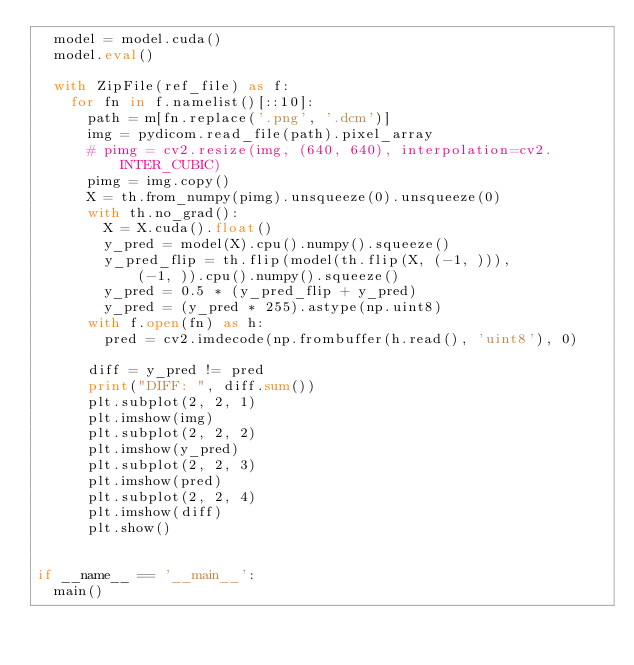<code> <loc_0><loc_0><loc_500><loc_500><_Python_>  model = model.cuda()
  model.eval()

  with ZipFile(ref_file) as f:
    for fn in f.namelist()[::10]:
      path = m[fn.replace('.png', '.dcm')]
      img = pydicom.read_file(path).pixel_array
      # pimg = cv2.resize(img, (640, 640), interpolation=cv2.INTER_CUBIC)
      pimg = img.copy()
      X = th.from_numpy(pimg).unsqueeze(0).unsqueeze(0)
      with th.no_grad():
        X = X.cuda().float()
        y_pred = model(X).cpu().numpy().squeeze()
        y_pred_flip = th.flip(model(th.flip(X, (-1, ))),
            (-1, )).cpu().numpy().squeeze()
        y_pred = 0.5 * (y_pred_flip + y_pred)
        y_pred = (y_pred * 255).astype(np.uint8)
      with f.open(fn) as h:
        pred = cv2.imdecode(np.frombuffer(h.read(), 'uint8'), 0)

      diff = y_pred != pred
      print("DIFF: ", diff.sum())
      plt.subplot(2, 2, 1)
      plt.imshow(img)
      plt.subplot(2, 2, 2)
      plt.imshow(y_pred)
      plt.subplot(2, 2, 3)
      plt.imshow(pred)
      plt.subplot(2, 2, 4)
      plt.imshow(diff)
      plt.show()


if __name__ == '__main__':
  main()
</code> 